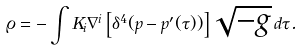<formula> <loc_0><loc_0><loc_500><loc_500>\varrho = - \int K _ { i } \nabla ^ { i } \left [ \delta ^ { 4 } ( p - p ^ { \prime } ( \tau ) ) \right ] \sqrt { - g } \, d \tau .</formula> 